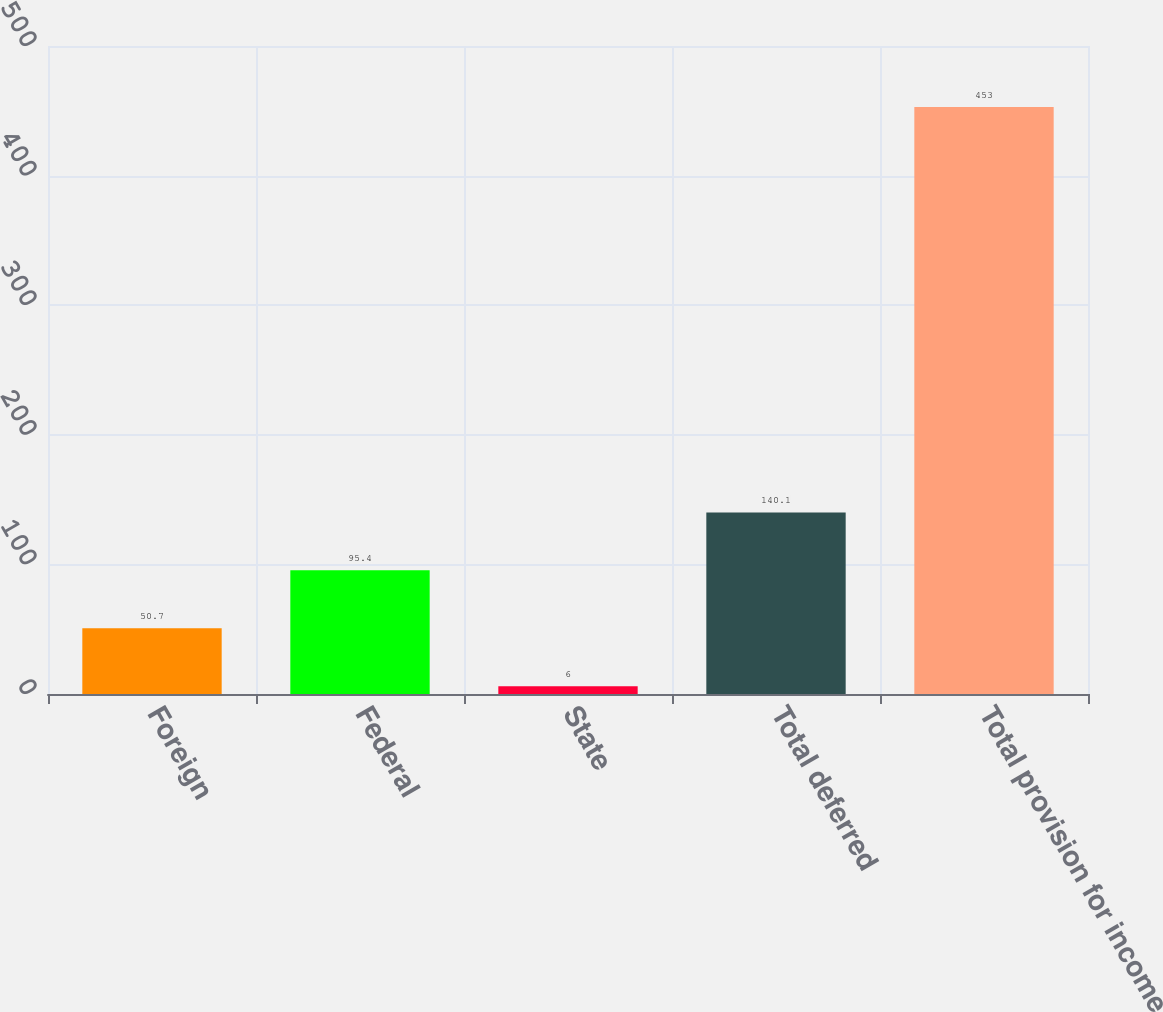Convert chart. <chart><loc_0><loc_0><loc_500><loc_500><bar_chart><fcel>Foreign<fcel>Federal<fcel>State<fcel>Total deferred<fcel>Total provision for income<nl><fcel>50.7<fcel>95.4<fcel>6<fcel>140.1<fcel>453<nl></chart> 